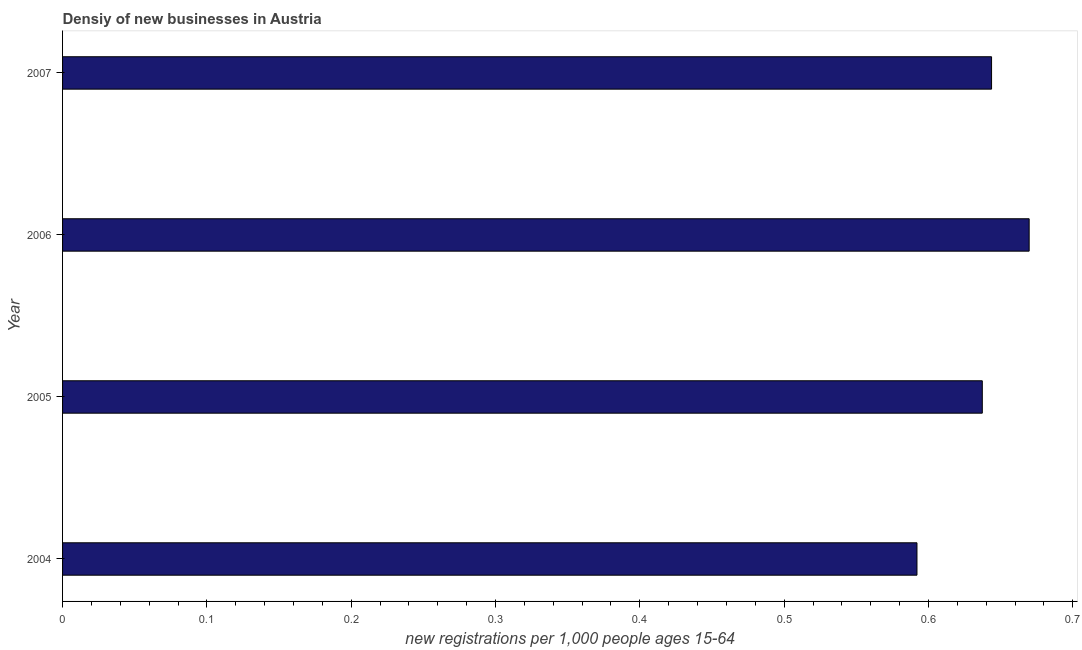Does the graph contain grids?
Your answer should be compact. No. What is the title of the graph?
Provide a short and direct response. Densiy of new businesses in Austria. What is the label or title of the X-axis?
Your response must be concise. New registrations per 1,0 people ages 15-64. What is the density of new business in 2007?
Give a very brief answer. 0.64. Across all years, what is the maximum density of new business?
Offer a very short reply. 0.67. Across all years, what is the minimum density of new business?
Make the answer very short. 0.59. In which year was the density of new business maximum?
Your answer should be very brief. 2006. What is the sum of the density of new business?
Your answer should be compact. 2.54. What is the difference between the density of new business in 2005 and 2006?
Provide a short and direct response. -0.03. What is the average density of new business per year?
Provide a short and direct response. 0.64. What is the median density of new business?
Your answer should be compact. 0.64. In how many years, is the density of new business greater than 0.6 ?
Keep it short and to the point. 3. Is the difference between the density of new business in 2005 and 2006 greater than the difference between any two years?
Keep it short and to the point. No. What is the difference between the highest and the second highest density of new business?
Make the answer very short. 0.03. How many bars are there?
Keep it short and to the point. 4. Are all the bars in the graph horizontal?
Offer a terse response. Yes. How many years are there in the graph?
Make the answer very short. 4. What is the difference between two consecutive major ticks on the X-axis?
Offer a very short reply. 0.1. Are the values on the major ticks of X-axis written in scientific E-notation?
Your response must be concise. No. What is the new registrations per 1,000 people ages 15-64 of 2004?
Your answer should be compact. 0.59. What is the new registrations per 1,000 people ages 15-64 of 2005?
Provide a succinct answer. 0.64. What is the new registrations per 1,000 people ages 15-64 in 2006?
Your answer should be very brief. 0.67. What is the new registrations per 1,000 people ages 15-64 of 2007?
Keep it short and to the point. 0.64. What is the difference between the new registrations per 1,000 people ages 15-64 in 2004 and 2005?
Make the answer very short. -0.05. What is the difference between the new registrations per 1,000 people ages 15-64 in 2004 and 2006?
Make the answer very short. -0.08. What is the difference between the new registrations per 1,000 people ages 15-64 in 2004 and 2007?
Offer a terse response. -0.05. What is the difference between the new registrations per 1,000 people ages 15-64 in 2005 and 2006?
Offer a terse response. -0.03. What is the difference between the new registrations per 1,000 people ages 15-64 in 2005 and 2007?
Ensure brevity in your answer.  -0.01. What is the difference between the new registrations per 1,000 people ages 15-64 in 2006 and 2007?
Give a very brief answer. 0.03. What is the ratio of the new registrations per 1,000 people ages 15-64 in 2004 to that in 2005?
Your answer should be compact. 0.93. What is the ratio of the new registrations per 1,000 people ages 15-64 in 2004 to that in 2006?
Offer a very short reply. 0.88. What is the ratio of the new registrations per 1,000 people ages 15-64 in 2005 to that in 2006?
Offer a very short reply. 0.95. What is the ratio of the new registrations per 1,000 people ages 15-64 in 2006 to that in 2007?
Make the answer very short. 1.04. 